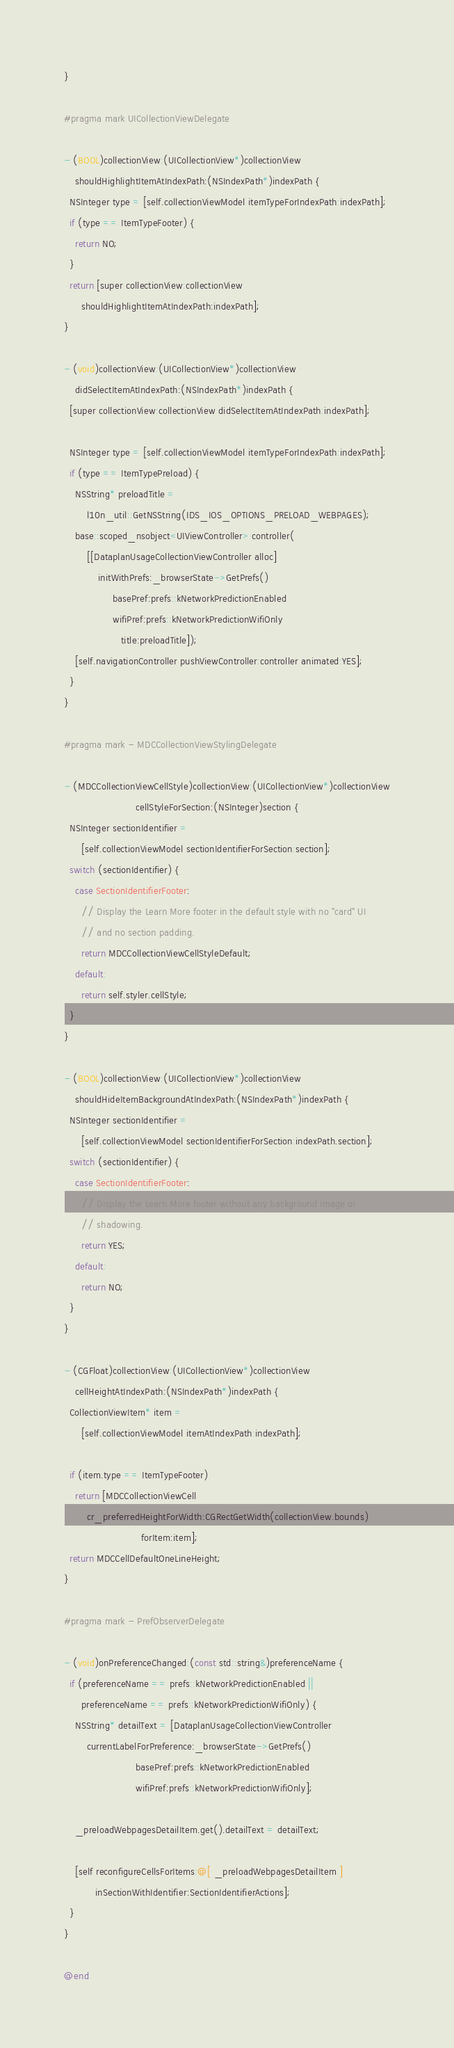Convert code to text. <code><loc_0><loc_0><loc_500><loc_500><_ObjectiveC_>}

#pragma mark UICollectionViewDelegate

- (BOOL)collectionView:(UICollectionView*)collectionView
    shouldHighlightItemAtIndexPath:(NSIndexPath*)indexPath {
  NSInteger type = [self.collectionViewModel itemTypeForIndexPath:indexPath];
  if (type == ItemTypeFooter) {
    return NO;
  }
  return [super collectionView:collectionView
      shouldHighlightItemAtIndexPath:indexPath];
}

- (void)collectionView:(UICollectionView*)collectionView
    didSelectItemAtIndexPath:(NSIndexPath*)indexPath {
  [super collectionView:collectionView didSelectItemAtIndexPath:indexPath];

  NSInteger type = [self.collectionViewModel itemTypeForIndexPath:indexPath];
  if (type == ItemTypePreload) {
    NSString* preloadTitle =
        l10n_util::GetNSString(IDS_IOS_OPTIONS_PRELOAD_WEBPAGES);
    base::scoped_nsobject<UIViewController> controller(
        [[DataplanUsageCollectionViewController alloc]
            initWithPrefs:_browserState->GetPrefs()
                 basePref:prefs::kNetworkPredictionEnabled
                 wifiPref:prefs::kNetworkPredictionWifiOnly
                    title:preloadTitle]);
    [self.navigationController pushViewController:controller animated:YES];
  }
}

#pragma mark - MDCCollectionViewStylingDelegate

- (MDCCollectionViewCellStyle)collectionView:(UICollectionView*)collectionView
                         cellStyleForSection:(NSInteger)section {
  NSInteger sectionIdentifier =
      [self.collectionViewModel sectionIdentifierForSection:section];
  switch (sectionIdentifier) {
    case SectionIdentifierFooter:
      // Display the Learn More footer in the default style with no "card" UI
      // and no section padding.
      return MDCCollectionViewCellStyleDefault;
    default:
      return self.styler.cellStyle;
  }
}

- (BOOL)collectionView:(UICollectionView*)collectionView
    shouldHideItemBackgroundAtIndexPath:(NSIndexPath*)indexPath {
  NSInteger sectionIdentifier =
      [self.collectionViewModel sectionIdentifierForSection:indexPath.section];
  switch (sectionIdentifier) {
    case SectionIdentifierFooter:
      // Display the Learn More footer without any background image or
      // shadowing.
      return YES;
    default:
      return NO;
  }
}

- (CGFloat)collectionView:(UICollectionView*)collectionView
    cellHeightAtIndexPath:(NSIndexPath*)indexPath {
  CollectionViewItem* item =
      [self.collectionViewModel itemAtIndexPath:indexPath];

  if (item.type == ItemTypeFooter)
    return [MDCCollectionViewCell
        cr_preferredHeightForWidth:CGRectGetWidth(collectionView.bounds)
                           forItem:item];
  return MDCCellDefaultOneLineHeight;
}

#pragma mark - PrefObserverDelegate

- (void)onPreferenceChanged:(const std::string&)preferenceName {
  if (preferenceName == prefs::kNetworkPredictionEnabled ||
      preferenceName == prefs::kNetworkPredictionWifiOnly) {
    NSString* detailText = [DataplanUsageCollectionViewController
        currentLabelForPreference:_browserState->GetPrefs()
                         basePref:prefs::kNetworkPredictionEnabled
                         wifiPref:prefs::kNetworkPredictionWifiOnly];

    _preloadWebpagesDetailItem.get().detailText = detailText;

    [self reconfigureCellsForItems:@[ _preloadWebpagesDetailItem ]
           inSectionWithIdentifier:SectionIdentifierActions];
  }
}

@end
</code> 